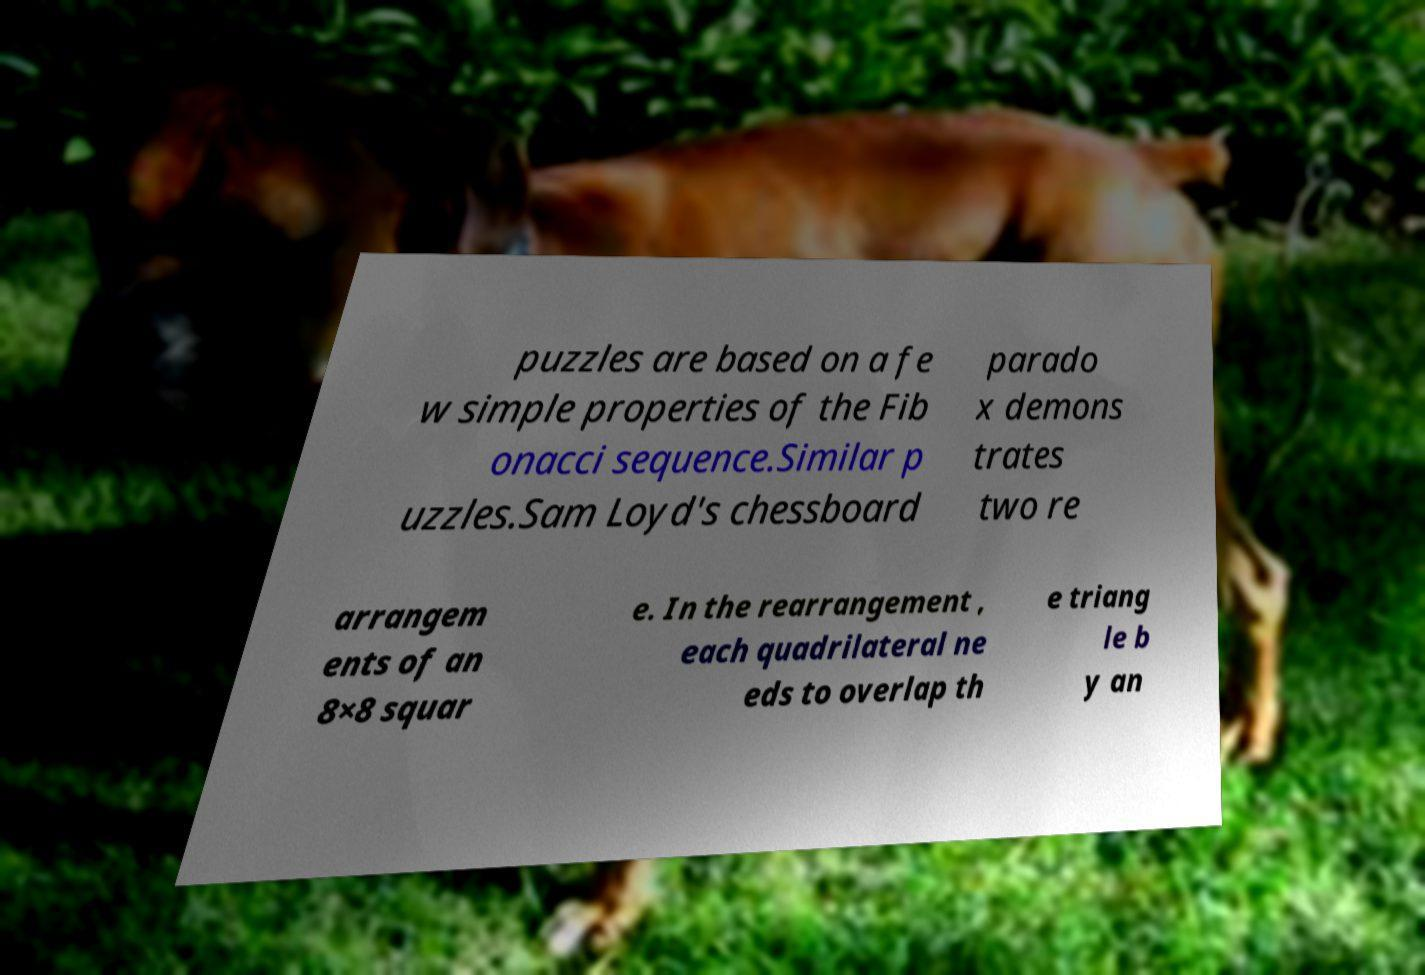Can you read and provide the text displayed in the image?This photo seems to have some interesting text. Can you extract and type it out for me? puzzles are based on a fe w simple properties of the Fib onacci sequence.Similar p uzzles.Sam Loyd's chessboard parado x demons trates two re arrangem ents of an 8×8 squar e. In the rearrangement , each quadrilateral ne eds to overlap th e triang le b y an 